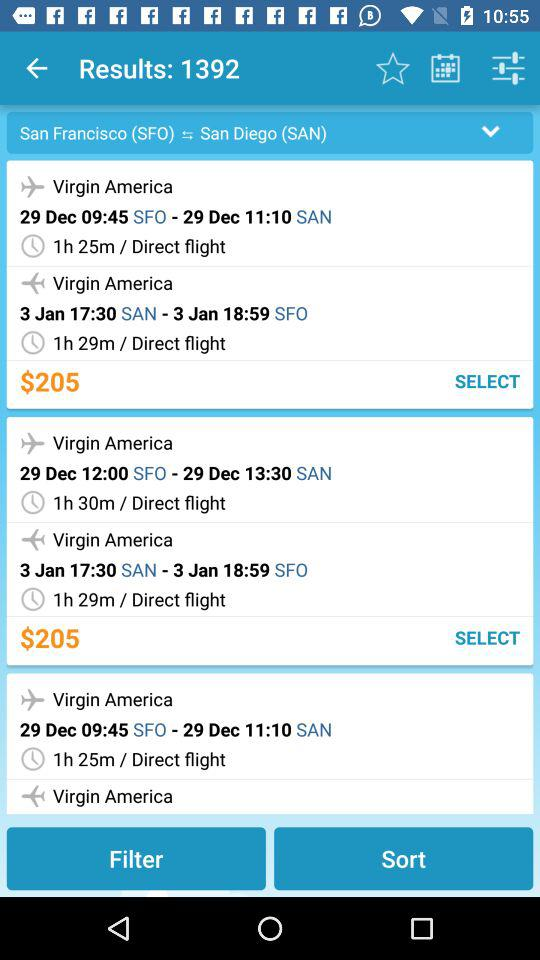What is the duration of a direct flight from SFO to SAN? The durations are 1 hour 25 minutes and 1 hour 30 minutes. 